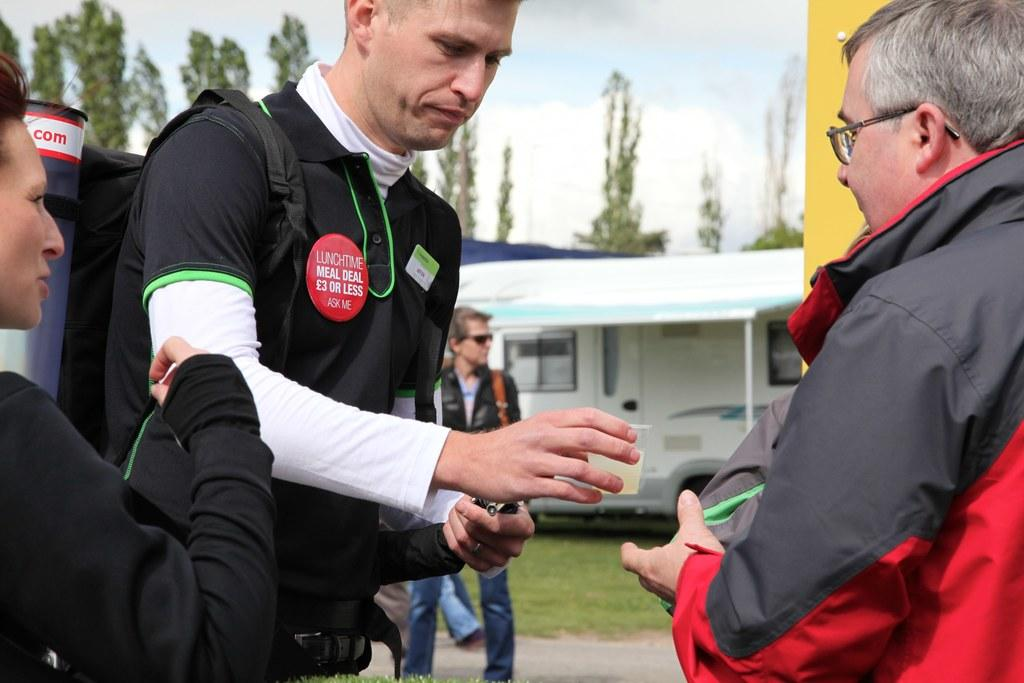Who is the main subject in the image? There is a man in the image. What is the man wearing? The man is wearing a black t-shirt. What is the man doing in the image? The man is giving a teacup to another person. Can you describe the person receiving the teacup? The person receiving the teacup is wearing a black and red jacket. What can be seen in the background of the image? There are trees visible in the background of the image. What color is the note that the man is holding in the image? There is no note visible in the image; the man is giving a teacup to another person. 